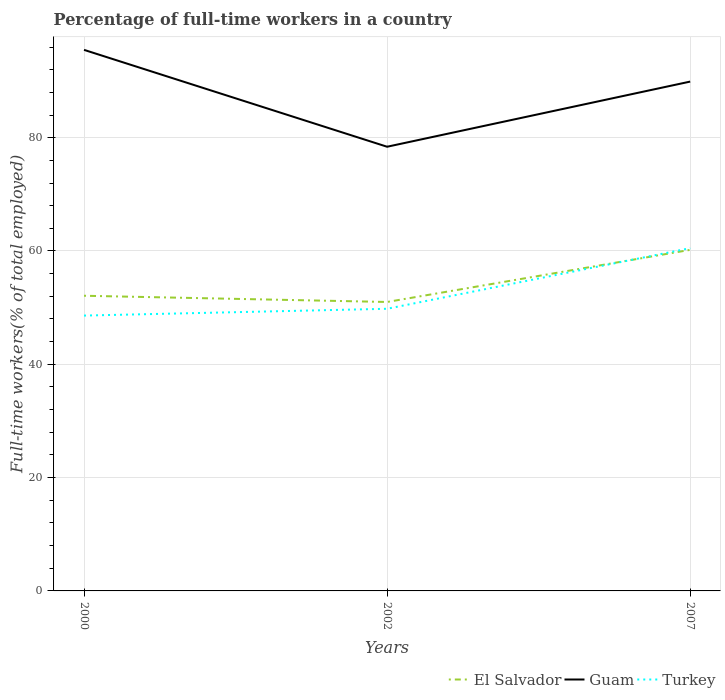Is the number of lines equal to the number of legend labels?
Your answer should be very brief. Yes. Across all years, what is the maximum percentage of full-time workers in Guam?
Keep it short and to the point. 78.4. What is the difference between the highest and the second highest percentage of full-time workers in Turkey?
Make the answer very short. 11.9. What is the difference between the highest and the lowest percentage of full-time workers in El Salvador?
Ensure brevity in your answer.  1. Is the percentage of full-time workers in Guam strictly greater than the percentage of full-time workers in Turkey over the years?
Ensure brevity in your answer.  No. What is the difference between two consecutive major ticks on the Y-axis?
Provide a short and direct response. 20. Are the values on the major ticks of Y-axis written in scientific E-notation?
Your response must be concise. No. Does the graph contain any zero values?
Your answer should be very brief. No. Does the graph contain grids?
Ensure brevity in your answer.  Yes. Where does the legend appear in the graph?
Provide a short and direct response. Bottom right. How many legend labels are there?
Make the answer very short. 3. How are the legend labels stacked?
Make the answer very short. Horizontal. What is the title of the graph?
Give a very brief answer. Percentage of full-time workers in a country. Does "Lesotho" appear as one of the legend labels in the graph?
Offer a terse response. No. What is the label or title of the Y-axis?
Offer a terse response. Full-time workers(% of total employed). What is the Full-time workers(% of total employed) in El Salvador in 2000?
Offer a very short reply. 52.1. What is the Full-time workers(% of total employed) in Guam in 2000?
Ensure brevity in your answer.  95.5. What is the Full-time workers(% of total employed) of Turkey in 2000?
Offer a terse response. 48.6. What is the Full-time workers(% of total employed) of El Salvador in 2002?
Provide a short and direct response. 51. What is the Full-time workers(% of total employed) of Guam in 2002?
Keep it short and to the point. 78.4. What is the Full-time workers(% of total employed) of Turkey in 2002?
Give a very brief answer. 49.8. What is the Full-time workers(% of total employed) of El Salvador in 2007?
Provide a short and direct response. 60.2. What is the Full-time workers(% of total employed) of Guam in 2007?
Your answer should be very brief. 89.9. What is the Full-time workers(% of total employed) of Turkey in 2007?
Ensure brevity in your answer.  60.5. Across all years, what is the maximum Full-time workers(% of total employed) in El Salvador?
Ensure brevity in your answer.  60.2. Across all years, what is the maximum Full-time workers(% of total employed) of Guam?
Ensure brevity in your answer.  95.5. Across all years, what is the maximum Full-time workers(% of total employed) of Turkey?
Ensure brevity in your answer.  60.5. Across all years, what is the minimum Full-time workers(% of total employed) in El Salvador?
Provide a succinct answer. 51. Across all years, what is the minimum Full-time workers(% of total employed) in Guam?
Offer a terse response. 78.4. Across all years, what is the minimum Full-time workers(% of total employed) in Turkey?
Your answer should be very brief. 48.6. What is the total Full-time workers(% of total employed) in El Salvador in the graph?
Make the answer very short. 163.3. What is the total Full-time workers(% of total employed) of Guam in the graph?
Provide a succinct answer. 263.8. What is the total Full-time workers(% of total employed) in Turkey in the graph?
Provide a short and direct response. 158.9. What is the difference between the Full-time workers(% of total employed) in El Salvador in 2000 and that in 2002?
Your response must be concise. 1.1. What is the difference between the Full-time workers(% of total employed) of El Salvador in 2002 and that in 2007?
Ensure brevity in your answer.  -9.2. What is the difference between the Full-time workers(% of total employed) in El Salvador in 2000 and the Full-time workers(% of total employed) in Guam in 2002?
Provide a succinct answer. -26.3. What is the difference between the Full-time workers(% of total employed) of El Salvador in 2000 and the Full-time workers(% of total employed) of Turkey in 2002?
Provide a short and direct response. 2.3. What is the difference between the Full-time workers(% of total employed) in Guam in 2000 and the Full-time workers(% of total employed) in Turkey in 2002?
Offer a terse response. 45.7. What is the difference between the Full-time workers(% of total employed) of El Salvador in 2000 and the Full-time workers(% of total employed) of Guam in 2007?
Provide a succinct answer. -37.8. What is the difference between the Full-time workers(% of total employed) of Guam in 2000 and the Full-time workers(% of total employed) of Turkey in 2007?
Give a very brief answer. 35. What is the difference between the Full-time workers(% of total employed) of El Salvador in 2002 and the Full-time workers(% of total employed) of Guam in 2007?
Offer a very short reply. -38.9. What is the difference between the Full-time workers(% of total employed) of El Salvador in 2002 and the Full-time workers(% of total employed) of Turkey in 2007?
Offer a terse response. -9.5. What is the average Full-time workers(% of total employed) of El Salvador per year?
Provide a short and direct response. 54.43. What is the average Full-time workers(% of total employed) in Guam per year?
Your response must be concise. 87.93. What is the average Full-time workers(% of total employed) of Turkey per year?
Your answer should be compact. 52.97. In the year 2000, what is the difference between the Full-time workers(% of total employed) in El Salvador and Full-time workers(% of total employed) in Guam?
Your response must be concise. -43.4. In the year 2000, what is the difference between the Full-time workers(% of total employed) in El Salvador and Full-time workers(% of total employed) in Turkey?
Offer a terse response. 3.5. In the year 2000, what is the difference between the Full-time workers(% of total employed) in Guam and Full-time workers(% of total employed) in Turkey?
Your answer should be compact. 46.9. In the year 2002, what is the difference between the Full-time workers(% of total employed) in El Salvador and Full-time workers(% of total employed) in Guam?
Make the answer very short. -27.4. In the year 2002, what is the difference between the Full-time workers(% of total employed) of Guam and Full-time workers(% of total employed) of Turkey?
Keep it short and to the point. 28.6. In the year 2007, what is the difference between the Full-time workers(% of total employed) of El Salvador and Full-time workers(% of total employed) of Guam?
Make the answer very short. -29.7. In the year 2007, what is the difference between the Full-time workers(% of total employed) of El Salvador and Full-time workers(% of total employed) of Turkey?
Your answer should be compact. -0.3. In the year 2007, what is the difference between the Full-time workers(% of total employed) in Guam and Full-time workers(% of total employed) in Turkey?
Make the answer very short. 29.4. What is the ratio of the Full-time workers(% of total employed) of El Salvador in 2000 to that in 2002?
Your answer should be compact. 1.02. What is the ratio of the Full-time workers(% of total employed) of Guam in 2000 to that in 2002?
Ensure brevity in your answer.  1.22. What is the ratio of the Full-time workers(% of total employed) of Turkey in 2000 to that in 2002?
Offer a very short reply. 0.98. What is the ratio of the Full-time workers(% of total employed) of El Salvador in 2000 to that in 2007?
Provide a short and direct response. 0.87. What is the ratio of the Full-time workers(% of total employed) in Guam in 2000 to that in 2007?
Provide a short and direct response. 1.06. What is the ratio of the Full-time workers(% of total employed) in Turkey in 2000 to that in 2007?
Provide a short and direct response. 0.8. What is the ratio of the Full-time workers(% of total employed) in El Salvador in 2002 to that in 2007?
Give a very brief answer. 0.85. What is the ratio of the Full-time workers(% of total employed) in Guam in 2002 to that in 2007?
Make the answer very short. 0.87. What is the ratio of the Full-time workers(% of total employed) of Turkey in 2002 to that in 2007?
Provide a short and direct response. 0.82. What is the difference between the highest and the second highest Full-time workers(% of total employed) of El Salvador?
Offer a very short reply. 8.1. What is the difference between the highest and the second highest Full-time workers(% of total employed) of Turkey?
Your response must be concise. 10.7. What is the difference between the highest and the lowest Full-time workers(% of total employed) of El Salvador?
Ensure brevity in your answer.  9.2. What is the difference between the highest and the lowest Full-time workers(% of total employed) of Turkey?
Make the answer very short. 11.9. 